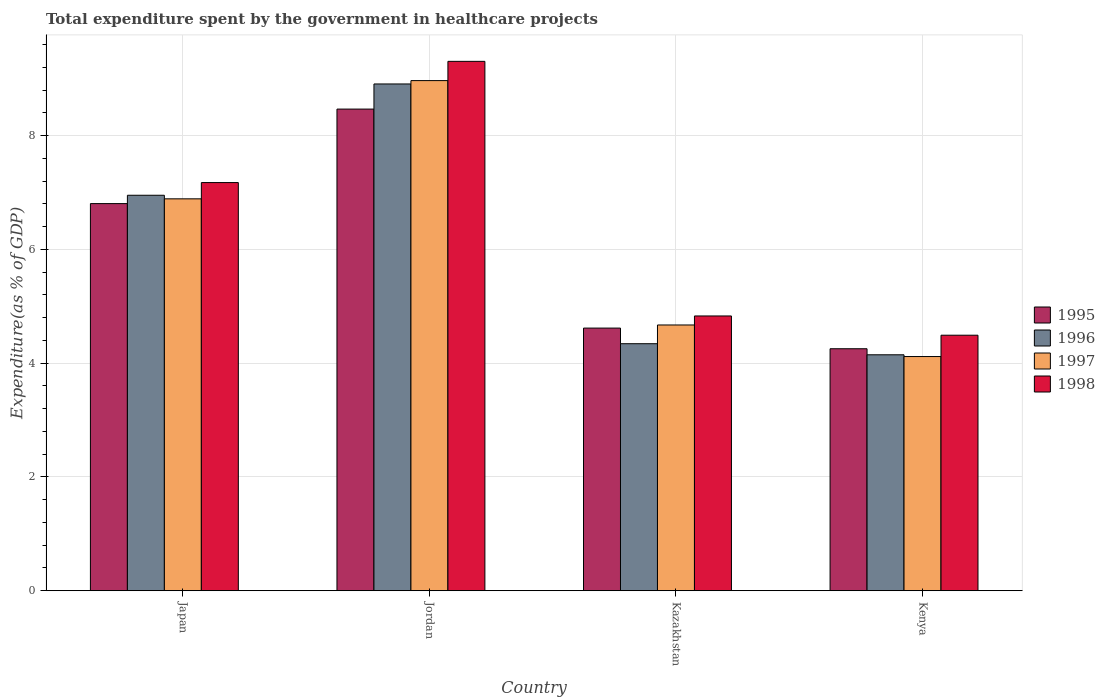Are the number of bars on each tick of the X-axis equal?
Give a very brief answer. Yes. How many bars are there on the 3rd tick from the right?
Your answer should be very brief. 4. What is the label of the 4th group of bars from the left?
Keep it short and to the point. Kenya. In how many cases, is the number of bars for a given country not equal to the number of legend labels?
Your answer should be compact. 0. What is the total expenditure spent by the government in healthcare projects in 1997 in Jordan?
Your answer should be compact. 8.97. Across all countries, what is the maximum total expenditure spent by the government in healthcare projects in 1997?
Keep it short and to the point. 8.97. Across all countries, what is the minimum total expenditure spent by the government in healthcare projects in 1996?
Ensure brevity in your answer.  4.15. In which country was the total expenditure spent by the government in healthcare projects in 1996 maximum?
Make the answer very short. Jordan. In which country was the total expenditure spent by the government in healthcare projects in 1998 minimum?
Offer a very short reply. Kenya. What is the total total expenditure spent by the government in healthcare projects in 1997 in the graph?
Your response must be concise. 24.65. What is the difference between the total expenditure spent by the government in healthcare projects in 1998 in Kazakhstan and that in Kenya?
Offer a terse response. 0.34. What is the difference between the total expenditure spent by the government in healthcare projects in 1995 in Kazakhstan and the total expenditure spent by the government in healthcare projects in 1996 in Kenya?
Your response must be concise. 0.47. What is the average total expenditure spent by the government in healthcare projects in 1995 per country?
Provide a short and direct response. 6.04. What is the difference between the total expenditure spent by the government in healthcare projects of/in 1997 and total expenditure spent by the government in healthcare projects of/in 1996 in Jordan?
Your answer should be very brief. 0.06. What is the ratio of the total expenditure spent by the government in healthcare projects in 1995 in Kazakhstan to that in Kenya?
Provide a short and direct response. 1.09. Is the difference between the total expenditure spent by the government in healthcare projects in 1997 in Japan and Kenya greater than the difference between the total expenditure spent by the government in healthcare projects in 1996 in Japan and Kenya?
Your answer should be compact. No. What is the difference between the highest and the second highest total expenditure spent by the government in healthcare projects in 1998?
Offer a very short reply. 4.48. What is the difference between the highest and the lowest total expenditure spent by the government in healthcare projects in 1995?
Your answer should be compact. 4.21. In how many countries, is the total expenditure spent by the government in healthcare projects in 1998 greater than the average total expenditure spent by the government in healthcare projects in 1998 taken over all countries?
Your answer should be compact. 2. Is it the case that in every country, the sum of the total expenditure spent by the government in healthcare projects in 1995 and total expenditure spent by the government in healthcare projects in 1998 is greater than the sum of total expenditure spent by the government in healthcare projects in 1997 and total expenditure spent by the government in healthcare projects in 1996?
Provide a succinct answer. No. What does the 1st bar from the left in Kazakhstan represents?
Ensure brevity in your answer.  1995. Is it the case that in every country, the sum of the total expenditure spent by the government in healthcare projects in 1998 and total expenditure spent by the government in healthcare projects in 1995 is greater than the total expenditure spent by the government in healthcare projects in 1996?
Keep it short and to the point. Yes. Are all the bars in the graph horizontal?
Offer a very short reply. No. How many countries are there in the graph?
Make the answer very short. 4. Are the values on the major ticks of Y-axis written in scientific E-notation?
Your response must be concise. No. Does the graph contain any zero values?
Ensure brevity in your answer.  No. Does the graph contain grids?
Keep it short and to the point. Yes. How many legend labels are there?
Provide a short and direct response. 4. What is the title of the graph?
Ensure brevity in your answer.  Total expenditure spent by the government in healthcare projects. Does "1997" appear as one of the legend labels in the graph?
Your answer should be very brief. Yes. What is the label or title of the X-axis?
Ensure brevity in your answer.  Country. What is the label or title of the Y-axis?
Offer a terse response. Expenditure(as % of GDP). What is the Expenditure(as % of GDP) in 1995 in Japan?
Your answer should be compact. 6.81. What is the Expenditure(as % of GDP) in 1996 in Japan?
Your answer should be compact. 6.95. What is the Expenditure(as % of GDP) of 1997 in Japan?
Your response must be concise. 6.89. What is the Expenditure(as % of GDP) of 1998 in Japan?
Your response must be concise. 7.18. What is the Expenditure(as % of GDP) in 1995 in Jordan?
Your answer should be compact. 8.47. What is the Expenditure(as % of GDP) of 1996 in Jordan?
Ensure brevity in your answer.  8.91. What is the Expenditure(as % of GDP) of 1997 in Jordan?
Your response must be concise. 8.97. What is the Expenditure(as % of GDP) of 1998 in Jordan?
Your answer should be very brief. 9.31. What is the Expenditure(as % of GDP) in 1995 in Kazakhstan?
Your response must be concise. 4.62. What is the Expenditure(as % of GDP) in 1996 in Kazakhstan?
Make the answer very short. 4.34. What is the Expenditure(as % of GDP) in 1997 in Kazakhstan?
Your answer should be very brief. 4.67. What is the Expenditure(as % of GDP) of 1998 in Kazakhstan?
Ensure brevity in your answer.  4.83. What is the Expenditure(as % of GDP) in 1995 in Kenya?
Offer a terse response. 4.25. What is the Expenditure(as % of GDP) in 1996 in Kenya?
Provide a succinct answer. 4.15. What is the Expenditure(as % of GDP) in 1997 in Kenya?
Ensure brevity in your answer.  4.12. What is the Expenditure(as % of GDP) in 1998 in Kenya?
Provide a short and direct response. 4.49. Across all countries, what is the maximum Expenditure(as % of GDP) in 1995?
Provide a succinct answer. 8.47. Across all countries, what is the maximum Expenditure(as % of GDP) of 1996?
Make the answer very short. 8.91. Across all countries, what is the maximum Expenditure(as % of GDP) of 1997?
Give a very brief answer. 8.97. Across all countries, what is the maximum Expenditure(as % of GDP) in 1998?
Provide a succinct answer. 9.31. Across all countries, what is the minimum Expenditure(as % of GDP) in 1995?
Your response must be concise. 4.25. Across all countries, what is the minimum Expenditure(as % of GDP) of 1996?
Provide a short and direct response. 4.15. Across all countries, what is the minimum Expenditure(as % of GDP) of 1997?
Offer a very short reply. 4.12. Across all countries, what is the minimum Expenditure(as % of GDP) of 1998?
Provide a succinct answer. 4.49. What is the total Expenditure(as % of GDP) in 1995 in the graph?
Offer a terse response. 24.15. What is the total Expenditure(as % of GDP) in 1996 in the graph?
Your answer should be very brief. 24.36. What is the total Expenditure(as % of GDP) in 1997 in the graph?
Your answer should be very brief. 24.65. What is the total Expenditure(as % of GDP) of 1998 in the graph?
Your response must be concise. 25.81. What is the difference between the Expenditure(as % of GDP) of 1995 in Japan and that in Jordan?
Your response must be concise. -1.66. What is the difference between the Expenditure(as % of GDP) in 1996 in Japan and that in Jordan?
Provide a short and direct response. -1.96. What is the difference between the Expenditure(as % of GDP) in 1997 in Japan and that in Jordan?
Ensure brevity in your answer.  -2.08. What is the difference between the Expenditure(as % of GDP) in 1998 in Japan and that in Jordan?
Your answer should be compact. -2.13. What is the difference between the Expenditure(as % of GDP) of 1995 in Japan and that in Kazakhstan?
Give a very brief answer. 2.19. What is the difference between the Expenditure(as % of GDP) in 1996 in Japan and that in Kazakhstan?
Keep it short and to the point. 2.61. What is the difference between the Expenditure(as % of GDP) of 1997 in Japan and that in Kazakhstan?
Offer a very short reply. 2.22. What is the difference between the Expenditure(as % of GDP) in 1998 in Japan and that in Kazakhstan?
Offer a terse response. 2.35. What is the difference between the Expenditure(as % of GDP) in 1995 in Japan and that in Kenya?
Offer a very short reply. 2.55. What is the difference between the Expenditure(as % of GDP) of 1996 in Japan and that in Kenya?
Your answer should be very brief. 2.81. What is the difference between the Expenditure(as % of GDP) in 1997 in Japan and that in Kenya?
Offer a terse response. 2.77. What is the difference between the Expenditure(as % of GDP) of 1998 in Japan and that in Kenya?
Provide a succinct answer. 2.68. What is the difference between the Expenditure(as % of GDP) of 1995 in Jordan and that in Kazakhstan?
Your answer should be compact. 3.85. What is the difference between the Expenditure(as % of GDP) of 1996 in Jordan and that in Kazakhstan?
Your response must be concise. 4.57. What is the difference between the Expenditure(as % of GDP) of 1997 in Jordan and that in Kazakhstan?
Provide a succinct answer. 4.3. What is the difference between the Expenditure(as % of GDP) of 1998 in Jordan and that in Kazakhstan?
Provide a succinct answer. 4.48. What is the difference between the Expenditure(as % of GDP) of 1995 in Jordan and that in Kenya?
Your answer should be very brief. 4.21. What is the difference between the Expenditure(as % of GDP) of 1996 in Jordan and that in Kenya?
Offer a terse response. 4.76. What is the difference between the Expenditure(as % of GDP) of 1997 in Jordan and that in Kenya?
Keep it short and to the point. 4.85. What is the difference between the Expenditure(as % of GDP) in 1998 in Jordan and that in Kenya?
Keep it short and to the point. 4.82. What is the difference between the Expenditure(as % of GDP) of 1995 in Kazakhstan and that in Kenya?
Your response must be concise. 0.36. What is the difference between the Expenditure(as % of GDP) of 1996 in Kazakhstan and that in Kenya?
Give a very brief answer. 0.19. What is the difference between the Expenditure(as % of GDP) in 1997 in Kazakhstan and that in Kenya?
Offer a terse response. 0.56. What is the difference between the Expenditure(as % of GDP) in 1998 in Kazakhstan and that in Kenya?
Ensure brevity in your answer.  0.34. What is the difference between the Expenditure(as % of GDP) of 1995 in Japan and the Expenditure(as % of GDP) of 1996 in Jordan?
Your response must be concise. -2.1. What is the difference between the Expenditure(as % of GDP) of 1995 in Japan and the Expenditure(as % of GDP) of 1997 in Jordan?
Offer a very short reply. -2.16. What is the difference between the Expenditure(as % of GDP) of 1995 in Japan and the Expenditure(as % of GDP) of 1998 in Jordan?
Offer a very short reply. -2.5. What is the difference between the Expenditure(as % of GDP) of 1996 in Japan and the Expenditure(as % of GDP) of 1997 in Jordan?
Offer a terse response. -2.02. What is the difference between the Expenditure(as % of GDP) of 1996 in Japan and the Expenditure(as % of GDP) of 1998 in Jordan?
Provide a short and direct response. -2.35. What is the difference between the Expenditure(as % of GDP) of 1997 in Japan and the Expenditure(as % of GDP) of 1998 in Jordan?
Provide a short and direct response. -2.42. What is the difference between the Expenditure(as % of GDP) of 1995 in Japan and the Expenditure(as % of GDP) of 1996 in Kazakhstan?
Provide a succinct answer. 2.46. What is the difference between the Expenditure(as % of GDP) of 1995 in Japan and the Expenditure(as % of GDP) of 1997 in Kazakhstan?
Provide a succinct answer. 2.13. What is the difference between the Expenditure(as % of GDP) in 1995 in Japan and the Expenditure(as % of GDP) in 1998 in Kazakhstan?
Ensure brevity in your answer.  1.98. What is the difference between the Expenditure(as % of GDP) in 1996 in Japan and the Expenditure(as % of GDP) in 1997 in Kazakhstan?
Provide a succinct answer. 2.28. What is the difference between the Expenditure(as % of GDP) in 1996 in Japan and the Expenditure(as % of GDP) in 1998 in Kazakhstan?
Your response must be concise. 2.12. What is the difference between the Expenditure(as % of GDP) in 1997 in Japan and the Expenditure(as % of GDP) in 1998 in Kazakhstan?
Provide a short and direct response. 2.06. What is the difference between the Expenditure(as % of GDP) of 1995 in Japan and the Expenditure(as % of GDP) of 1996 in Kenya?
Give a very brief answer. 2.66. What is the difference between the Expenditure(as % of GDP) in 1995 in Japan and the Expenditure(as % of GDP) in 1997 in Kenya?
Provide a succinct answer. 2.69. What is the difference between the Expenditure(as % of GDP) of 1995 in Japan and the Expenditure(as % of GDP) of 1998 in Kenya?
Make the answer very short. 2.31. What is the difference between the Expenditure(as % of GDP) of 1996 in Japan and the Expenditure(as % of GDP) of 1997 in Kenya?
Offer a terse response. 2.84. What is the difference between the Expenditure(as % of GDP) in 1996 in Japan and the Expenditure(as % of GDP) in 1998 in Kenya?
Make the answer very short. 2.46. What is the difference between the Expenditure(as % of GDP) of 1997 in Japan and the Expenditure(as % of GDP) of 1998 in Kenya?
Keep it short and to the point. 2.4. What is the difference between the Expenditure(as % of GDP) of 1995 in Jordan and the Expenditure(as % of GDP) of 1996 in Kazakhstan?
Provide a short and direct response. 4.13. What is the difference between the Expenditure(as % of GDP) in 1995 in Jordan and the Expenditure(as % of GDP) in 1997 in Kazakhstan?
Give a very brief answer. 3.8. What is the difference between the Expenditure(as % of GDP) of 1995 in Jordan and the Expenditure(as % of GDP) of 1998 in Kazakhstan?
Make the answer very short. 3.64. What is the difference between the Expenditure(as % of GDP) of 1996 in Jordan and the Expenditure(as % of GDP) of 1997 in Kazakhstan?
Give a very brief answer. 4.24. What is the difference between the Expenditure(as % of GDP) in 1996 in Jordan and the Expenditure(as % of GDP) in 1998 in Kazakhstan?
Provide a succinct answer. 4.08. What is the difference between the Expenditure(as % of GDP) of 1997 in Jordan and the Expenditure(as % of GDP) of 1998 in Kazakhstan?
Your response must be concise. 4.14. What is the difference between the Expenditure(as % of GDP) of 1995 in Jordan and the Expenditure(as % of GDP) of 1996 in Kenya?
Offer a very short reply. 4.32. What is the difference between the Expenditure(as % of GDP) in 1995 in Jordan and the Expenditure(as % of GDP) in 1997 in Kenya?
Offer a terse response. 4.35. What is the difference between the Expenditure(as % of GDP) of 1995 in Jordan and the Expenditure(as % of GDP) of 1998 in Kenya?
Your answer should be compact. 3.98. What is the difference between the Expenditure(as % of GDP) in 1996 in Jordan and the Expenditure(as % of GDP) in 1997 in Kenya?
Your response must be concise. 4.79. What is the difference between the Expenditure(as % of GDP) of 1996 in Jordan and the Expenditure(as % of GDP) of 1998 in Kenya?
Offer a very short reply. 4.42. What is the difference between the Expenditure(as % of GDP) in 1997 in Jordan and the Expenditure(as % of GDP) in 1998 in Kenya?
Provide a short and direct response. 4.48. What is the difference between the Expenditure(as % of GDP) in 1995 in Kazakhstan and the Expenditure(as % of GDP) in 1996 in Kenya?
Provide a succinct answer. 0.47. What is the difference between the Expenditure(as % of GDP) of 1995 in Kazakhstan and the Expenditure(as % of GDP) of 1997 in Kenya?
Offer a terse response. 0.5. What is the difference between the Expenditure(as % of GDP) in 1995 in Kazakhstan and the Expenditure(as % of GDP) in 1998 in Kenya?
Make the answer very short. 0.13. What is the difference between the Expenditure(as % of GDP) of 1996 in Kazakhstan and the Expenditure(as % of GDP) of 1997 in Kenya?
Your response must be concise. 0.23. What is the difference between the Expenditure(as % of GDP) of 1996 in Kazakhstan and the Expenditure(as % of GDP) of 1998 in Kenya?
Make the answer very short. -0.15. What is the difference between the Expenditure(as % of GDP) of 1997 in Kazakhstan and the Expenditure(as % of GDP) of 1998 in Kenya?
Provide a succinct answer. 0.18. What is the average Expenditure(as % of GDP) of 1995 per country?
Offer a very short reply. 6.04. What is the average Expenditure(as % of GDP) of 1996 per country?
Offer a very short reply. 6.09. What is the average Expenditure(as % of GDP) in 1997 per country?
Provide a short and direct response. 6.16. What is the average Expenditure(as % of GDP) of 1998 per country?
Make the answer very short. 6.45. What is the difference between the Expenditure(as % of GDP) of 1995 and Expenditure(as % of GDP) of 1996 in Japan?
Make the answer very short. -0.15. What is the difference between the Expenditure(as % of GDP) of 1995 and Expenditure(as % of GDP) of 1997 in Japan?
Provide a succinct answer. -0.08. What is the difference between the Expenditure(as % of GDP) of 1995 and Expenditure(as % of GDP) of 1998 in Japan?
Keep it short and to the point. -0.37. What is the difference between the Expenditure(as % of GDP) in 1996 and Expenditure(as % of GDP) in 1997 in Japan?
Your answer should be very brief. 0.06. What is the difference between the Expenditure(as % of GDP) of 1996 and Expenditure(as % of GDP) of 1998 in Japan?
Your answer should be compact. -0.22. What is the difference between the Expenditure(as % of GDP) of 1997 and Expenditure(as % of GDP) of 1998 in Japan?
Keep it short and to the point. -0.29. What is the difference between the Expenditure(as % of GDP) in 1995 and Expenditure(as % of GDP) in 1996 in Jordan?
Your response must be concise. -0.44. What is the difference between the Expenditure(as % of GDP) of 1995 and Expenditure(as % of GDP) of 1997 in Jordan?
Your answer should be compact. -0.5. What is the difference between the Expenditure(as % of GDP) of 1995 and Expenditure(as % of GDP) of 1998 in Jordan?
Ensure brevity in your answer.  -0.84. What is the difference between the Expenditure(as % of GDP) of 1996 and Expenditure(as % of GDP) of 1997 in Jordan?
Your answer should be compact. -0.06. What is the difference between the Expenditure(as % of GDP) in 1996 and Expenditure(as % of GDP) in 1998 in Jordan?
Offer a terse response. -0.4. What is the difference between the Expenditure(as % of GDP) in 1997 and Expenditure(as % of GDP) in 1998 in Jordan?
Provide a succinct answer. -0.34. What is the difference between the Expenditure(as % of GDP) of 1995 and Expenditure(as % of GDP) of 1996 in Kazakhstan?
Offer a very short reply. 0.27. What is the difference between the Expenditure(as % of GDP) in 1995 and Expenditure(as % of GDP) in 1997 in Kazakhstan?
Offer a very short reply. -0.05. What is the difference between the Expenditure(as % of GDP) in 1995 and Expenditure(as % of GDP) in 1998 in Kazakhstan?
Make the answer very short. -0.21. What is the difference between the Expenditure(as % of GDP) in 1996 and Expenditure(as % of GDP) in 1997 in Kazakhstan?
Offer a very short reply. -0.33. What is the difference between the Expenditure(as % of GDP) of 1996 and Expenditure(as % of GDP) of 1998 in Kazakhstan?
Your answer should be very brief. -0.49. What is the difference between the Expenditure(as % of GDP) in 1997 and Expenditure(as % of GDP) in 1998 in Kazakhstan?
Offer a terse response. -0.16. What is the difference between the Expenditure(as % of GDP) in 1995 and Expenditure(as % of GDP) in 1996 in Kenya?
Offer a very short reply. 0.11. What is the difference between the Expenditure(as % of GDP) of 1995 and Expenditure(as % of GDP) of 1997 in Kenya?
Give a very brief answer. 0.14. What is the difference between the Expenditure(as % of GDP) in 1995 and Expenditure(as % of GDP) in 1998 in Kenya?
Offer a terse response. -0.24. What is the difference between the Expenditure(as % of GDP) of 1996 and Expenditure(as % of GDP) of 1997 in Kenya?
Give a very brief answer. 0.03. What is the difference between the Expenditure(as % of GDP) in 1996 and Expenditure(as % of GDP) in 1998 in Kenya?
Offer a terse response. -0.34. What is the difference between the Expenditure(as % of GDP) in 1997 and Expenditure(as % of GDP) in 1998 in Kenya?
Offer a terse response. -0.38. What is the ratio of the Expenditure(as % of GDP) in 1995 in Japan to that in Jordan?
Give a very brief answer. 0.8. What is the ratio of the Expenditure(as % of GDP) of 1996 in Japan to that in Jordan?
Make the answer very short. 0.78. What is the ratio of the Expenditure(as % of GDP) in 1997 in Japan to that in Jordan?
Give a very brief answer. 0.77. What is the ratio of the Expenditure(as % of GDP) of 1998 in Japan to that in Jordan?
Make the answer very short. 0.77. What is the ratio of the Expenditure(as % of GDP) in 1995 in Japan to that in Kazakhstan?
Your answer should be compact. 1.47. What is the ratio of the Expenditure(as % of GDP) of 1996 in Japan to that in Kazakhstan?
Provide a short and direct response. 1.6. What is the ratio of the Expenditure(as % of GDP) in 1997 in Japan to that in Kazakhstan?
Your answer should be compact. 1.47. What is the ratio of the Expenditure(as % of GDP) of 1998 in Japan to that in Kazakhstan?
Keep it short and to the point. 1.49. What is the ratio of the Expenditure(as % of GDP) in 1995 in Japan to that in Kenya?
Your response must be concise. 1.6. What is the ratio of the Expenditure(as % of GDP) of 1996 in Japan to that in Kenya?
Ensure brevity in your answer.  1.68. What is the ratio of the Expenditure(as % of GDP) of 1997 in Japan to that in Kenya?
Keep it short and to the point. 1.67. What is the ratio of the Expenditure(as % of GDP) of 1998 in Japan to that in Kenya?
Ensure brevity in your answer.  1.6. What is the ratio of the Expenditure(as % of GDP) of 1995 in Jordan to that in Kazakhstan?
Give a very brief answer. 1.83. What is the ratio of the Expenditure(as % of GDP) of 1996 in Jordan to that in Kazakhstan?
Give a very brief answer. 2.05. What is the ratio of the Expenditure(as % of GDP) of 1997 in Jordan to that in Kazakhstan?
Your answer should be very brief. 1.92. What is the ratio of the Expenditure(as % of GDP) of 1998 in Jordan to that in Kazakhstan?
Provide a short and direct response. 1.93. What is the ratio of the Expenditure(as % of GDP) of 1995 in Jordan to that in Kenya?
Make the answer very short. 1.99. What is the ratio of the Expenditure(as % of GDP) of 1996 in Jordan to that in Kenya?
Provide a short and direct response. 2.15. What is the ratio of the Expenditure(as % of GDP) of 1997 in Jordan to that in Kenya?
Provide a succinct answer. 2.18. What is the ratio of the Expenditure(as % of GDP) in 1998 in Jordan to that in Kenya?
Ensure brevity in your answer.  2.07. What is the ratio of the Expenditure(as % of GDP) of 1995 in Kazakhstan to that in Kenya?
Provide a short and direct response. 1.09. What is the ratio of the Expenditure(as % of GDP) in 1996 in Kazakhstan to that in Kenya?
Ensure brevity in your answer.  1.05. What is the ratio of the Expenditure(as % of GDP) of 1997 in Kazakhstan to that in Kenya?
Provide a short and direct response. 1.13. What is the ratio of the Expenditure(as % of GDP) of 1998 in Kazakhstan to that in Kenya?
Provide a short and direct response. 1.08. What is the difference between the highest and the second highest Expenditure(as % of GDP) in 1995?
Offer a terse response. 1.66. What is the difference between the highest and the second highest Expenditure(as % of GDP) in 1996?
Provide a short and direct response. 1.96. What is the difference between the highest and the second highest Expenditure(as % of GDP) in 1997?
Your answer should be compact. 2.08. What is the difference between the highest and the second highest Expenditure(as % of GDP) of 1998?
Your answer should be very brief. 2.13. What is the difference between the highest and the lowest Expenditure(as % of GDP) in 1995?
Offer a very short reply. 4.21. What is the difference between the highest and the lowest Expenditure(as % of GDP) of 1996?
Provide a succinct answer. 4.76. What is the difference between the highest and the lowest Expenditure(as % of GDP) of 1997?
Your answer should be very brief. 4.85. What is the difference between the highest and the lowest Expenditure(as % of GDP) in 1998?
Offer a very short reply. 4.82. 